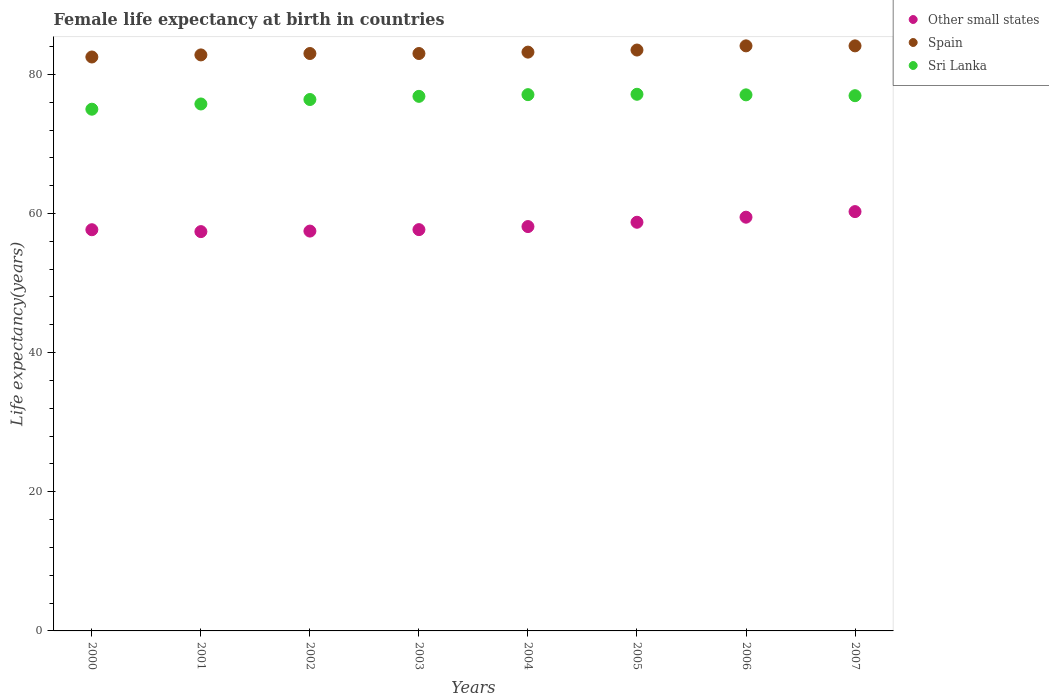How many different coloured dotlines are there?
Keep it short and to the point. 3. Is the number of dotlines equal to the number of legend labels?
Make the answer very short. Yes. What is the female life expectancy at birth in Other small states in 2005?
Offer a terse response. 58.74. Across all years, what is the maximum female life expectancy at birth in Other small states?
Provide a short and direct response. 60.28. Across all years, what is the minimum female life expectancy at birth in Spain?
Provide a succinct answer. 82.5. In which year was the female life expectancy at birth in Spain minimum?
Ensure brevity in your answer.  2000. What is the total female life expectancy at birth in Other small states in the graph?
Provide a succinct answer. 466.84. What is the difference between the female life expectancy at birth in Spain in 2000 and that in 2001?
Ensure brevity in your answer.  -0.3. What is the difference between the female life expectancy at birth in Sri Lanka in 2001 and the female life expectancy at birth in Other small states in 2007?
Your answer should be very brief. 15.47. What is the average female life expectancy at birth in Sri Lanka per year?
Provide a short and direct response. 76.52. In the year 2000, what is the difference between the female life expectancy at birth in Other small states and female life expectancy at birth in Sri Lanka?
Offer a very short reply. -17.32. In how many years, is the female life expectancy at birth in Other small states greater than 36 years?
Offer a terse response. 8. What is the ratio of the female life expectancy at birth in Other small states in 2003 to that in 2005?
Provide a short and direct response. 0.98. What is the difference between the highest and the second highest female life expectancy at birth in Other small states?
Offer a terse response. 0.8. What is the difference between the highest and the lowest female life expectancy at birth in Spain?
Ensure brevity in your answer.  1.6. Is the sum of the female life expectancy at birth in Other small states in 2001 and 2005 greater than the maximum female life expectancy at birth in Sri Lanka across all years?
Provide a succinct answer. Yes. How many dotlines are there?
Give a very brief answer. 3. Does the graph contain any zero values?
Offer a very short reply. No. Does the graph contain grids?
Keep it short and to the point. No. Where does the legend appear in the graph?
Make the answer very short. Top right. How are the legend labels stacked?
Keep it short and to the point. Vertical. What is the title of the graph?
Your answer should be compact. Female life expectancy at birth in countries. Does "Cameroon" appear as one of the legend labels in the graph?
Your response must be concise. No. What is the label or title of the Y-axis?
Make the answer very short. Life expectancy(years). What is the Life expectancy(years) of Other small states in 2000?
Give a very brief answer. 57.67. What is the Life expectancy(years) of Spain in 2000?
Offer a very short reply. 82.5. What is the Life expectancy(years) in Sri Lanka in 2000?
Provide a short and direct response. 75. What is the Life expectancy(years) of Other small states in 2001?
Provide a succinct answer. 57.4. What is the Life expectancy(years) in Spain in 2001?
Your response must be concise. 82.8. What is the Life expectancy(years) of Sri Lanka in 2001?
Provide a succinct answer. 75.75. What is the Life expectancy(years) of Other small states in 2002?
Your answer should be very brief. 57.47. What is the Life expectancy(years) in Spain in 2002?
Ensure brevity in your answer.  83. What is the Life expectancy(years) of Sri Lanka in 2002?
Give a very brief answer. 76.39. What is the Life expectancy(years) in Other small states in 2003?
Give a very brief answer. 57.68. What is the Life expectancy(years) of Spain in 2003?
Offer a very short reply. 83. What is the Life expectancy(years) of Sri Lanka in 2003?
Provide a succinct answer. 76.84. What is the Life expectancy(years) of Other small states in 2004?
Offer a terse response. 58.12. What is the Life expectancy(years) in Spain in 2004?
Keep it short and to the point. 83.2. What is the Life expectancy(years) of Sri Lanka in 2004?
Make the answer very short. 77.09. What is the Life expectancy(years) of Other small states in 2005?
Your answer should be compact. 58.74. What is the Life expectancy(years) of Spain in 2005?
Give a very brief answer. 83.5. What is the Life expectancy(years) in Sri Lanka in 2005?
Provide a short and direct response. 77.14. What is the Life expectancy(years) in Other small states in 2006?
Make the answer very short. 59.47. What is the Life expectancy(years) in Spain in 2006?
Offer a very short reply. 84.1. What is the Life expectancy(years) of Sri Lanka in 2006?
Give a very brief answer. 77.06. What is the Life expectancy(years) of Other small states in 2007?
Your answer should be compact. 60.28. What is the Life expectancy(years) in Spain in 2007?
Provide a short and direct response. 84.1. What is the Life expectancy(years) of Sri Lanka in 2007?
Your response must be concise. 76.94. Across all years, what is the maximum Life expectancy(years) of Other small states?
Your answer should be compact. 60.28. Across all years, what is the maximum Life expectancy(years) in Spain?
Your answer should be compact. 84.1. Across all years, what is the maximum Life expectancy(years) of Sri Lanka?
Offer a very short reply. 77.14. Across all years, what is the minimum Life expectancy(years) in Other small states?
Give a very brief answer. 57.4. Across all years, what is the minimum Life expectancy(years) of Spain?
Offer a very short reply. 82.5. Across all years, what is the minimum Life expectancy(years) in Sri Lanka?
Provide a short and direct response. 75. What is the total Life expectancy(years) in Other small states in the graph?
Ensure brevity in your answer.  466.84. What is the total Life expectancy(years) in Spain in the graph?
Give a very brief answer. 666.2. What is the total Life expectancy(years) of Sri Lanka in the graph?
Give a very brief answer. 612.19. What is the difference between the Life expectancy(years) in Other small states in 2000 and that in 2001?
Offer a very short reply. 0.27. What is the difference between the Life expectancy(years) in Spain in 2000 and that in 2001?
Offer a terse response. -0.3. What is the difference between the Life expectancy(years) in Sri Lanka in 2000 and that in 2001?
Provide a short and direct response. -0.75. What is the difference between the Life expectancy(years) of Other small states in 2000 and that in 2002?
Give a very brief answer. 0.2. What is the difference between the Life expectancy(years) in Sri Lanka in 2000 and that in 2002?
Your answer should be compact. -1.39. What is the difference between the Life expectancy(years) of Other small states in 2000 and that in 2003?
Give a very brief answer. -0.01. What is the difference between the Life expectancy(years) of Sri Lanka in 2000 and that in 2003?
Keep it short and to the point. -1.85. What is the difference between the Life expectancy(years) in Other small states in 2000 and that in 2004?
Your response must be concise. -0.45. What is the difference between the Life expectancy(years) in Sri Lanka in 2000 and that in 2004?
Your answer should be compact. -2.09. What is the difference between the Life expectancy(years) in Other small states in 2000 and that in 2005?
Keep it short and to the point. -1.07. What is the difference between the Life expectancy(years) of Sri Lanka in 2000 and that in 2005?
Offer a very short reply. -2.15. What is the difference between the Life expectancy(years) in Other small states in 2000 and that in 2006?
Offer a very short reply. -1.8. What is the difference between the Life expectancy(years) of Sri Lanka in 2000 and that in 2006?
Your answer should be compact. -2.06. What is the difference between the Life expectancy(years) of Other small states in 2000 and that in 2007?
Make the answer very short. -2.6. What is the difference between the Life expectancy(years) in Sri Lanka in 2000 and that in 2007?
Offer a very short reply. -1.94. What is the difference between the Life expectancy(years) of Other small states in 2001 and that in 2002?
Ensure brevity in your answer.  -0.08. What is the difference between the Life expectancy(years) in Spain in 2001 and that in 2002?
Your answer should be very brief. -0.2. What is the difference between the Life expectancy(years) of Sri Lanka in 2001 and that in 2002?
Provide a succinct answer. -0.64. What is the difference between the Life expectancy(years) in Other small states in 2001 and that in 2003?
Ensure brevity in your answer.  -0.29. What is the difference between the Life expectancy(years) of Spain in 2001 and that in 2003?
Your response must be concise. -0.2. What is the difference between the Life expectancy(years) in Sri Lanka in 2001 and that in 2003?
Your response must be concise. -1.1. What is the difference between the Life expectancy(years) of Other small states in 2001 and that in 2004?
Make the answer very short. -0.72. What is the difference between the Life expectancy(years) of Spain in 2001 and that in 2004?
Give a very brief answer. -0.4. What is the difference between the Life expectancy(years) of Sri Lanka in 2001 and that in 2004?
Your answer should be compact. -1.34. What is the difference between the Life expectancy(years) of Other small states in 2001 and that in 2005?
Ensure brevity in your answer.  -1.34. What is the difference between the Life expectancy(years) in Sri Lanka in 2001 and that in 2005?
Offer a very short reply. -1.39. What is the difference between the Life expectancy(years) in Other small states in 2001 and that in 2006?
Your answer should be very brief. -2.07. What is the difference between the Life expectancy(years) in Spain in 2001 and that in 2006?
Your answer should be very brief. -1.3. What is the difference between the Life expectancy(years) of Sri Lanka in 2001 and that in 2006?
Keep it short and to the point. -1.31. What is the difference between the Life expectancy(years) of Other small states in 2001 and that in 2007?
Provide a short and direct response. -2.88. What is the difference between the Life expectancy(years) of Sri Lanka in 2001 and that in 2007?
Your answer should be very brief. -1.19. What is the difference between the Life expectancy(years) of Other small states in 2002 and that in 2003?
Make the answer very short. -0.21. What is the difference between the Life expectancy(years) of Sri Lanka in 2002 and that in 2003?
Ensure brevity in your answer.  -0.46. What is the difference between the Life expectancy(years) in Other small states in 2002 and that in 2004?
Your answer should be very brief. -0.65. What is the difference between the Life expectancy(years) of Sri Lanka in 2002 and that in 2004?
Provide a short and direct response. -0.7. What is the difference between the Life expectancy(years) in Other small states in 2002 and that in 2005?
Provide a short and direct response. -1.27. What is the difference between the Life expectancy(years) in Spain in 2002 and that in 2005?
Your answer should be compact. -0.5. What is the difference between the Life expectancy(years) in Sri Lanka in 2002 and that in 2005?
Keep it short and to the point. -0.75. What is the difference between the Life expectancy(years) in Other small states in 2002 and that in 2006?
Give a very brief answer. -2. What is the difference between the Life expectancy(years) in Sri Lanka in 2002 and that in 2006?
Provide a succinct answer. -0.67. What is the difference between the Life expectancy(years) in Other small states in 2002 and that in 2007?
Make the answer very short. -2.8. What is the difference between the Life expectancy(years) in Sri Lanka in 2002 and that in 2007?
Your response must be concise. -0.55. What is the difference between the Life expectancy(years) of Other small states in 2003 and that in 2004?
Provide a short and direct response. -0.44. What is the difference between the Life expectancy(years) in Spain in 2003 and that in 2004?
Give a very brief answer. -0.2. What is the difference between the Life expectancy(years) of Sri Lanka in 2003 and that in 2004?
Provide a short and direct response. -0.24. What is the difference between the Life expectancy(years) in Other small states in 2003 and that in 2005?
Give a very brief answer. -1.06. What is the difference between the Life expectancy(years) in Spain in 2003 and that in 2005?
Make the answer very short. -0.5. What is the difference between the Life expectancy(years) of Sri Lanka in 2003 and that in 2005?
Provide a short and direct response. -0.3. What is the difference between the Life expectancy(years) of Other small states in 2003 and that in 2006?
Your response must be concise. -1.79. What is the difference between the Life expectancy(years) in Sri Lanka in 2003 and that in 2006?
Give a very brief answer. -0.21. What is the difference between the Life expectancy(years) of Other small states in 2003 and that in 2007?
Your answer should be compact. -2.59. What is the difference between the Life expectancy(years) in Sri Lanka in 2003 and that in 2007?
Provide a short and direct response. -0.09. What is the difference between the Life expectancy(years) in Other small states in 2004 and that in 2005?
Ensure brevity in your answer.  -0.62. What is the difference between the Life expectancy(years) in Sri Lanka in 2004 and that in 2005?
Make the answer very short. -0.05. What is the difference between the Life expectancy(years) in Other small states in 2004 and that in 2006?
Provide a succinct answer. -1.35. What is the difference between the Life expectancy(years) of Spain in 2004 and that in 2006?
Provide a short and direct response. -0.9. What is the difference between the Life expectancy(years) of Sri Lanka in 2004 and that in 2006?
Your answer should be very brief. 0.03. What is the difference between the Life expectancy(years) of Other small states in 2004 and that in 2007?
Make the answer very short. -2.15. What is the difference between the Life expectancy(years) in Sri Lanka in 2004 and that in 2007?
Offer a very short reply. 0.15. What is the difference between the Life expectancy(years) in Other small states in 2005 and that in 2006?
Offer a terse response. -0.73. What is the difference between the Life expectancy(years) in Sri Lanka in 2005 and that in 2006?
Ensure brevity in your answer.  0.08. What is the difference between the Life expectancy(years) of Other small states in 2005 and that in 2007?
Ensure brevity in your answer.  -1.53. What is the difference between the Life expectancy(years) of Sri Lanka in 2005 and that in 2007?
Your answer should be compact. 0.2. What is the difference between the Life expectancy(years) of Other small states in 2006 and that in 2007?
Ensure brevity in your answer.  -0.8. What is the difference between the Life expectancy(years) of Sri Lanka in 2006 and that in 2007?
Keep it short and to the point. 0.12. What is the difference between the Life expectancy(years) in Other small states in 2000 and the Life expectancy(years) in Spain in 2001?
Offer a terse response. -25.13. What is the difference between the Life expectancy(years) in Other small states in 2000 and the Life expectancy(years) in Sri Lanka in 2001?
Your answer should be very brief. -18.07. What is the difference between the Life expectancy(years) of Spain in 2000 and the Life expectancy(years) of Sri Lanka in 2001?
Provide a succinct answer. 6.75. What is the difference between the Life expectancy(years) of Other small states in 2000 and the Life expectancy(years) of Spain in 2002?
Provide a succinct answer. -25.33. What is the difference between the Life expectancy(years) of Other small states in 2000 and the Life expectancy(years) of Sri Lanka in 2002?
Ensure brevity in your answer.  -18.72. What is the difference between the Life expectancy(years) of Spain in 2000 and the Life expectancy(years) of Sri Lanka in 2002?
Keep it short and to the point. 6.11. What is the difference between the Life expectancy(years) in Other small states in 2000 and the Life expectancy(years) in Spain in 2003?
Give a very brief answer. -25.33. What is the difference between the Life expectancy(years) of Other small states in 2000 and the Life expectancy(years) of Sri Lanka in 2003?
Your answer should be compact. -19.17. What is the difference between the Life expectancy(years) of Spain in 2000 and the Life expectancy(years) of Sri Lanka in 2003?
Offer a very short reply. 5.66. What is the difference between the Life expectancy(years) in Other small states in 2000 and the Life expectancy(years) in Spain in 2004?
Ensure brevity in your answer.  -25.53. What is the difference between the Life expectancy(years) in Other small states in 2000 and the Life expectancy(years) in Sri Lanka in 2004?
Your response must be concise. -19.42. What is the difference between the Life expectancy(years) of Spain in 2000 and the Life expectancy(years) of Sri Lanka in 2004?
Offer a very short reply. 5.41. What is the difference between the Life expectancy(years) of Other small states in 2000 and the Life expectancy(years) of Spain in 2005?
Keep it short and to the point. -25.83. What is the difference between the Life expectancy(years) of Other small states in 2000 and the Life expectancy(years) of Sri Lanka in 2005?
Ensure brevity in your answer.  -19.47. What is the difference between the Life expectancy(years) in Spain in 2000 and the Life expectancy(years) in Sri Lanka in 2005?
Your response must be concise. 5.36. What is the difference between the Life expectancy(years) in Other small states in 2000 and the Life expectancy(years) in Spain in 2006?
Ensure brevity in your answer.  -26.43. What is the difference between the Life expectancy(years) of Other small states in 2000 and the Life expectancy(years) of Sri Lanka in 2006?
Offer a very short reply. -19.39. What is the difference between the Life expectancy(years) in Spain in 2000 and the Life expectancy(years) in Sri Lanka in 2006?
Your answer should be compact. 5.44. What is the difference between the Life expectancy(years) of Other small states in 2000 and the Life expectancy(years) of Spain in 2007?
Your response must be concise. -26.43. What is the difference between the Life expectancy(years) of Other small states in 2000 and the Life expectancy(years) of Sri Lanka in 2007?
Provide a succinct answer. -19.27. What is the difference between the Life expectancy(years) in Spain in 2000 and the Life expectancy(years) in Sri Lanka in 2007?
Your answer should be compact. 5.56. What is the difference between the Life expectancy(years) of Other small states in 2001 and the Life expectancy(years) of Spain in 2002?
Ensure brevity in your answer.  -25.6. What is the difference between the Life expectancy(years) of Other small states in 2001 and the Life expectancy(years) of Sri Lanka in 2002?
Your response must be concise. -18.99. What is the difference between the Life expectancy(years) in Spain in 2001 and the Life expectancy(years) in Sri Lanka in 2002?
Your answer should be compact. 6.41. What is the difference between the Life expectancy(years) in Other small states in 2001 and the Life expectancy(years) in Spain in 2003?
Your answer should be very brief. -25.6. What is the difference between the Life expectancy(years) of Other small states in 2001 and the Life expectancy(years) of Sri Lanka in 2003?
Ensure brevity in your answer.  -19.44. What is the difference between the Life expectancy(years) in Spain in 2001 and the Life expectancy(years) in Sri Lanka in 2003?
Your response must be concise. 5.96. What is the difference between the Life expectancy(years) of Other small states in 2001 and the Life expectancy(years) of Spain in 2004?
Offer a very short reply. -25.8. What is the difference between the Life expectancy(years) of Other small states in 2001 and the Life expectancy(years) of Sri Lanka in 2004?
Keep it short and to the point. -19.69. What is the difference between the Life expectancy(years) in Spain in 2001 and the Life expectancy(years) in Sri Lanka in 2004?
Provide a short and direct response. 5.71. What is the difference between the Life expectancy(years) of Other small states in 2001 and the Life expectancy(years) of Spain in 2005?
Ensure brevity in your answer.  -26.1. What is the difference between the Life expectancy(years) of Other small states in 2001 and the Life expectancy(years) of Sri Lanka in 2005?
Ensure brevity in your answer.  -19.74. What is the difference between the Life expectancy(years) in Spain in 2001 and the Life expectancy(years) in Sri Lanka in 2005?
Make the answer very short. 5.66. What is the difference between the Life expectancy(years) in Other small states in 2001 and the Life expectancy(years) in Spain in 2006?
Your response must be concise. -26.7. What is the difference between the Life expectancy(years) in Other small states in 2001 and the Life expectancy(years) in Sri Lanka in 2006?
Keep it short and to the point. -19.66. What is the difference between the Life expectancy(years) in Spain in 2001 and the Life expectancy(years) in Sri Lanka in 2006?
Provide a short and direct response. 5.74. What is the difference between the Life expectancy(years) in Other small states in 2001 and the Life expectancy(years) in Spain in 2007?
Your response must be concise. -26.7. What is the difference between the Life expectancy(years) in Other small states in 2001 and the Life expectancy(years) in Sri Lanka in 2007?
Provide a succinct answer. -19.54. What is the difference between the Life expectancy(years) in Spain in 2001 and the Life expectancy(years) in Sri Lanka in 2007?
Provide a short and direct response. 5.86. What is the difference between the Life expectancy(years) in Other small states in 2002 and the Life expectancy(years) in Spain in 2003?
Your response must be concise. -25.53. What is the difference between the Life expectancy(years) of Other small states in 2002 and the Life expectancy(years) of Sri Lanka in 2003?
Make the answer very short. -19.37. What is the difference between the Life expectancy(years) in Spain in 2002 and the Life expectancy(years) in Sri Lanka in 2003?
Ensure brevity in your answer.  6.16. What is the difference between the Life expectancy(years) of Other small states in 2002 and the Life expectancy(years) of Spain in 2004?
Keep it short and to the point. -25.73. What is the difference between the Life expectancy(years) in Other small states in 2002 and the Life expectancy(years) in Sri Lanka in 2004?
Keep it short and to the point. -19.61. What is the difference between the Life expectancy(years) in Spain in 2002 and the Life expectancy(years) in Sri Lanka in 2004?
Keep it short and to the point. 5.91. What is the difference between the Life expectancy(years) in Other small states in 2002 and the Life expectancy(years) in Spain in 2005?
Provide a succinct answer. -26.03. What is the difference between the Life expectancy(years) of Other small states in 2002 and the Life expectancy(years) of Sri Lanka in 2005?
Your answer should be compact. -19.67. What is the difference between the Life expectancy(years) in Spain in 2002 and the Life expectancy(years) in Sri Lanka in 2005?
Offer a very short reply. 5.86. What is the difference between the Life expectancy(years) in Other small states in 2002 and the Life expectancy(years) in Spain in 2006?
Your answer should be compact. -26.63. What is the difference between the Life expectancy(years) in Other small states in 2002 and the Life expectancy(years) in Sri Lanka in 2006?
Offer a very short reply. -19.58. What is the difference between the Life expectancy(years) of Spain in 2002 and the Life expectancy(years) of Sri Lanka in 2006?
Give a very brief answer. 5.94. What is the difference between the Life expectancy(years) of Other small states in 2002 and the Life expectancy(years) of Spain in 2007?
Offer a very short reply. -26.63. What is the difference between the Life expectancy(years) in Other small states in 2002 and the Life expectancy(years) in Sri Lanka in 2007?
Offer a very short reply. -19.46. What is the difference between the Life expectancy(years) of Spain in 2002 and the Life expectancy(years) of Sri Lanka in 2007?
Make the answer very short. 6.06. What is the difference between the Life expectancy(years) in Other small states in 2003 and the Life expectancy(years) in Spain in 2004?
Provide a short and direct response. -25.52. What is the difference between the Life expectancy(years) of Other small states in 2003 and the Life expectancy(years) of Sri Lanka in 2004?
Offer a terse response. -19.4. What is the difference between the Life expectancy(years) in Spain in 2003 and the Life expectancy(years) in Sri Lanka in 2004?
Provide a succinct answer. 5.91. What is the difference between the Life expectancy(years) of Other small states in 2003 and the Life expectancy(years) of Spain in 2005?
Give a very brief answer. -25.82. What is the difference between the Life expectancy(years) in Other small states in 2003 and the Life expectancy(years) in Sri Lanka in 2005?
Provide a succinct answer. -19.46. What is the difference between the Life expectancy(years) in Spain in 2003 and the Life expectancy(years) in Sri Lanka in 2005?
Offer a very short reply. 5.86. What is the difference between the Life expectancy(years) in Other small states in 2003 and the Life expectancy(years) in Spain in 2006?
Provide a succinct answer. -26.42. What is the difference between the Life expectancy(years) of Other small states in 2003 and the Life expectancy(years) of Sri Lanka in 2006?
Your answer should be compact. -19.37. What is the difference between the Life expectancy(years) in Spain in 2003 and the Life expectancy(years) in Sri Lanka in 2006?
Your answer should be very brief. 5.94. What is the difference between the Life expectancy(years) of Other small states in 2003 and the Life expectancy(years) of Spain in 2007?
Provide a succinct answer. -26.42. What is the difference between the Life expectancy(years) in Other small states in 2003 and the Life expectancy(years) in Sri Lanka in 2007?
Offer a very short reply. -19.25. What is the difference between the Life expectancy(years) in Spain in 2003 and the Life expectancy(years) in Sri Lanka in 2007?
Your answer should be very brief. 6.06. What is the difference between the Life expectancy(years) of Other small states in 2004 and the Life expectancy(years) of Spain in 2005?
Offer a terse response. -25.38. What is the difference between the Life expectancy(years) in Other small states in 2004 and the Life expectancy(years) in Sri Lanka in 2005?
Your answer should be very brief. -19.02. What is the difference between the Life expectancy(years) of Spain in 2004 and the Life expectancy(years) of Sri Lanka in 2005?
Provide a short and direct response. 6.06. What is the difference between the Life expectancy(years) in Other small states in 2004 and the Life expectancy(years) in Spain in 2006?
Give a very brief answer. -25.98. What is the difference between the Life expectancy(years) in Other small states in 2004 and the Life expectancy(years) in Sri Lanka in 2006?
Your answer should be very brief. -18.93. What is the difference between the Life expectancy(years) in Spain in 2004 and the Life expectancy(years) in Sri Lanka in 2006?
Offer a terse response. 6.14. What is the difference between the Life expectancy(years) in Other small states in 2004 and the Life expectancy(years) in Spain in 2007?
Make the answer very short. -25.98. What is the difference between the Life expectancy(years) in Other small states in 2004 and the Life expectancy(years) in Sri Lanka in 2007?
Provide a short and direct response. -18.81. What is the difference between the Life expectancy(years) of Spain in 2004 and the Life expectancy(years) of Sri Lanka in 2007?
Your answer should be compact. 6.26. What is the difference between the Life expectancy(years) in Other small states in 2005 and the Life expectancy(years) in Spain in 2006?
Your answer should be compact. -25.36. What is the difference between the Life expectancy(years) in Other small states in 2005 and the Life expectancy(years) in Sri Lanka in 2006?
Your answer should be compact. -18.31. What is the difference between the Life expectancy(years) in Spain in 2005 and the Life expectancy(years) in Sri Lanka in 2006?
Offer a very short reply. 6.44. What is the difference between the Life expectancy(years) of Other small states in 2005 and the Life expectancy(years) of Spain in 2007?
Keep it short and to the point. -25.36. What is the difference between the Life expectancy(years) in Other small states in 2005 and the Life expectancy(years) in Sri Lanka in 2007?
Offer a very short reply. -18.19. What is the difference between the Life expectancy(years) in Spain in 2005 and the Life expectancy(years) in Sri Lanka in 2007?
Provide a short and direct response. 6.56. What is the difference between the Life expectancy(years) in Other small states in 2006 and the Life expectancy(years) in Spain in 2007?
Your answer should be very brief. -24.63. What is the difference between the Life expectancy(years) of Other small states in 2006 and the Life expectancy(years) of Sri Lanka in 2007?
Offer a terse response. -17.46. What is the difference between the Life expectancy(years) in Spain in 2006 and the Life expectancy(years) in Sri Lanka in 2007?
Provide a short and direct response. 7.16. What is the average Life expectancy(years) of Other small states per year?
Your answer should be very brief. 58.36. What is the average Life expectancy(years) of Spain per year?
Your answer should be compact. 83.28. What is the average Life expectancy(years) in Sri Lanka per year?
Your answer should be very brief. 76.52. In the year 2000, what is the difference between the Life expectancy(years) in Other small states and Life expectancy(years) in Spain?
Your answer should be very brief. -24.83. In the year 2000, what is the difference between the Life expectancy(years) of Other small states and Life expectancy(years) of Sri Lanka?
Provide a short and direct response. -17.32. In the year 2000, what is the difference between the Life expectancy(years) in Spain and Life expectancy(years) in Sri Lanka?
Your answer should be compact. 7.5. In the year 2001, what is the difference between the Life expectancy(years) in Other small states and Life expectancy(years) in Spain?
Offer a very short reply. -25.4. In the year 2001, what is the difference between the Life expectancy(years) in Other small states and Life expectancy(years) in Sri Lanka?
Your answer should be compact. -18.35. In the year 2001, what is the difference between the Life expectancy(years) of Spain and Life expectancy(years) of Sri Lanka?
Offer a very short reply. 7.05. In the year 2002, what is the difference between the Life expectancy(years) of Other small states and Life expectancy(years) of Spain?
Your answer should be very brief. -25.53. In the year 2002, what is the difference between the Life expectancy(years) in Other small states and Life expectancy(years) in Sri Lanka?
Your response must be concise. -18.91. In the year 2002, what is the difference between the Life expectancy(years) of Spain and Life expectancy(years) of Sri Lanka?
Your response must be concise. 6.61. In the year 2003, what is the difference between the Life expectancy(years) in Other small states and Life expectancy(years) in Spain?
Provide a succinct answer. -25.32. In the year 2003, what is the difference between the Life expectancy(years) in Other small states and Life expectancy(years) in Sri Lanka?
Keep it short and to the point. -19.16. In the year 2003, what is the difference between the Life expectancy(years) in Spain and Life expectancy(years) in Sri Lanka?
Provide a succinct answer. 6.16. In the year 2004, what is the difference between the Life expectancy(years) in Other small states and Life expectancy(years) in Spain?
Offer a very short reply. -25.08. In the year 2004, what is the difference between the Life expectancy(years) in Other small states and Life expectancy(years) in Sri Lanka?
Provide a short and direct response. -18.96. In the year 2004, what is the difference between the Life expectancy(years) of Spain and Life expectancy(years) of Sri Lanka?
Your answer should be very brief. 6.11. In the year 2005, what is the difference between the Life expectancy(years) in Other small states and Life expectancy(years) in Spain?
Provide a short and direct response. -24.76. In the year 2005, what is the difference between the Life expectancy(years) in Other small states and Life expectancy(years) in Sri Lanka?
Your answer should be very brief. -18.4. In the year 2005, what is the difference between the Life expectancy(years) of Spain and Life expectancy(years) of Sri Lanka?
Your answer should be compact. 6.36. In the year 2006, what is the difference between the Life expectancy(years) of Other small states and Life expectancy(years) of Spain?
Ensure brevity in your answer.  -24.63. In the year 2006, what is the difference between the Life expectancy(years) of Other small states and Life expectancy(years) of Sri Lanka?
Provide a succinct answer. -17.59. In the year 2006, what is the difference between the Life expectancy(years) in Spain and Life expectancy(years) in Sri Lanka?
Provide a succinct answer. 7.04. In the year 2007, what is the difference between the Life expectancy(years) in Other small states and Life expectancy(years) in Spain?
Provide a succinct answer. -23.82. In the year 2007, what is the difference between the Life expectancy(years) in Other small states and Life expectancy(years) in Sri Lanka?
Make the answer very short. -16.66. In the year 2007, what is the difference between the Life expectancy(years) in Spain and Life expectancy(years) in Sri Lanka?
Your answer should be very brief. 7.16. What is the ratio of the Life expectancy(years) of Other small states in 2000 to that in 2001?
Your answer should be very brief. 1. What is the ratio of the Life expectancy(years) of Spain in 2000 to that in 2002?
Provide a succinct answer. 0.99. What is the ratio of the Life expectancy(years) in Sri Lanka in 2000 to that in 2002?
Your answer should be very brief. 0.98. What is the ratio of the Life expectancy(years) in Other small states in 2000 to that in 2003?
Your answer should be compact. 1. What is the ratio of the Life expectancy(years) in Spain in 2000 to that in 2003?
Your answer should be compact. 0.99. What is the ratio of the Life expectancy(years) of Spain in 2000 to that in 2004?
Your answer should be compact. 0.99. What is the ratio of the Life expectancy(years) in Sri Lanka in 2000 to that in 2004?
Provide a succinct answer. 0.97. What is the ratio of the Life expectancy(years) of Other small states in 2000 to that in 2005?
Offer a terse response. 0.98. What is the ratio of the Life expectancy(years) in Spain in 2000 to that in 2005?
Ensure brevity in your answer.  0.99. What is the ratio of the Life expectancy(years) in Sri Lanka in 2000 to that in 2005?
Offer a very short reply. 0.97. What is the ratio of the Life expectancy(years) of Other small states in 2000 to that in 2006?
Keep it short and to the point. 0.97. What is the ratio of the Life expectancy(years) in Sri Lanka in 2000 to that in 2006?
Provide a short and direct response. 0.97. What is the ratio of the Life expectancy(years) of Other small states in 2000 to that in 2007?
Provide a succinct answer. 0.96. What is the ratio of the Life expectancy(years) of Spain in 2000 to that in 2007?
Your answer should be very brief. 0.98. What is the ratio of the Life expectancy(years) of Sri Lanka in 2000 to that in 2007?
Offer a terse response. 0.97. What is the ratio of the Life expectancy(years) in Other small states in 2001 to that in 2002?
Ensure brevity in your answer.  1. What is the ratio of the Life expectancy(years) of Other small states in 2001 to that in 2003?
Your answer should be compact. 0.99. What is the ratio of the Life expectancy(years) in Spain in 2001 to that in 2003?
Keep it short and to the point. 1. What is the ratio of the Life expectancy(years) of Sri Lanka in 2001 to that in 2003?
Your answer should be very brief. 0.99. What is the ratio of the Life expectancy(years) of Other small states in 2001 to that in 2004?
Give a very brief answer. 0.99. What is the ratio of the Life expectancy(years) in Spain in 2001 to that in 2004?
Make the answer very short. 1. What is the ratio of the Life expectancy(years) of Sri Lanka in 2001 to that in 2004?
Give a very brief answer. 0.98. What is the ratio of the Life expectancy(years) of Other small states in 2001 to that in 2005?
Provide a succinct answer. 0.98. What is the ratio of the Life expectancy(years) of Spain in 2001 to that in 2005?
Provide a short and direct response. 0.99. What is the ratio of the Life expectancy(years) of Sri Lanka in 2001 to that in 2005?
Your answer should be compact. 0.98. What is the ratio of the Life expectancy(years) of Other small states in 2001 to that in 2006?
Give a very brief answer. 0.97. What is the ratio of the Life expectancy(years) in Spain in 2001 to that in 2006?
Keep it short and to the point. 0.98. What is the ratio of the Life expectancy(years) of Sri Lanka in 2001 to that in 2006?
Give a very brief answer. 0.98. What is the ratio of the Life expectancy(years) of Other small states in 2001 to that in 2007?
Give a very brief answer. 0.95. What is the ratio of the Life expectancy(years) in Spain in 2001 to that in 2007?
Offer a terse response. 0.98. What is the ratio of the Life expectancy(years) in Sri Lanka in 2001 to that in 2007?
Make the answer very short. 0.98. What is the ratio of the Life expectancy(years) in Other small states in 2002 to that in 2003?
Offer a very short reply. 1. What is the ratio of the Life expectancy(years) in Spain in 2002 to that in 2004?
Keep it short and to the point. 1. What is the ratio of the Life expectancy(years) of Sri Lanka in 2002 to that in 2004?
Give a very brief answer. 0.99. What is the ratio of the Life expectancy(years) of Other small states in 2002 to that in 2005?
Ensure brevity in your answer.  0.98. What is the ratio of the Life expectancy(years) in Sri Lanka in 2002 to that in 2005?
Your response must be concise. 0.99. What is the ratio of the Life expectancy(years) of Other small states in 2002 to that in 2006?
Offer a very short reply. 0.97. What is the ratio of the Life expectancy(years) in Spain in 2002 to that in 2006?
Offer a terse response. 0.99. What is the ratio of the Life expectancy(years) in Sri Lanka in 2002 to that in 2006?
Keep it short and to the point. 0.99. What is the ratio of the Life expectancy(years) of Other small states in 2002 to that in 2007?
Provide a short and direct response. 0.95. What is the ratio of the Life expectancy(years) in Spain in 2002 to that in 2007?
Provide a succinct answer. 0.99. What is the ratio of the Life expectancy(years) of Other small states in 2003 to that in 2004?
Provide a short and direct response. 0.99. What is the ratio of the Life expectancy(years) in Sri Lanka in 2003 to that in 2004?
Keep it short and to the point. 1. What is the ratio of the Life expectancy(years) of Spain in 2003 to that in 2005?
Your answer should be very brief. 0.99. What is the ratio of the Life expectancy(years) of Other small states in 2003 to that in 2006?
Offer a very short reply. 0.97. What is the ratio of the Life expectancy(years) of Spain in 2003 to that in 2006?
Make the answer very short. 0.99. What is the ratio of the Life expectancy(years) of Spain in 2003 to that in 2007?
Offer a very short reply. 0.99. What is the ratio of the Life expectancy(years) in Other small states in 2004 to that in 2005?
Provide a short and direct response. 0.99. What is the ratio of the Life expectancy(years) in Spain in 2004 to that in 2005?
Provide a succinct answer. 1. What is the ratio of the Life expectancy(years) of Other small states in 2004 to that in 2006?
Make the answer very short. 0.98. What is the ratio of the Life expectancy(years) of Spain in 2004 to that in 2006?
Provide a succinct answer. 0.99. What is the ratio of the Life expectancy(years) of Other small states in 2004 to that in 2007?
Ensure brevity in your answer.  0.96. What is the ratio of the Life expectancy(years) in Spain in 2004 to that in 2007?
Make the answer very short. 0.99. What is the ratio of the Life expectancy(years) in Sri Lanka in 2004 to that in 2007?
Offer a terse response. 1. What is the ratio of the Life expectancy(years) of Other small states in 2005 to that in 2006?
Your answer should be very brief. 0.99. What is the ratio of the Life expectancy(years) of Sri Lanka in 2005 to that in 2006?
Your response must be concise. 1. What is the ratio of the Life expectancy(years) in Other small states in 2005 to that in 2007?
Give a very brief answer. 0.97. What is the ratio of the Life expectancy(years) in Sri Lanka in 2005 to that in 2007?
Offer a terse response. 1. What is the ratio of the Life expectancy(years) of Other small states in 2006 to that in 2007?
Ensure brevity in your answer.  0.99. What is the ratio of the Life expectancy(years) in Spain in 2006 to that in 2007?
Your answer should be very brief. 1. What is the difference between the highest and the second highest Life expectancy(years) of Other small states?
Provide a short and direct response. 0.8. What is the difference between the highest and the second highest Life expectancy(years) of Spain?
Provide a succinct answer. 0. What is the difference between the highest and the second highest Life expectancy(years) of Sri Lanka?
Offer a terse response. 0.05. What is the difference between the highest and the lowest Life expectancy(years) in Other small states?
Your response must be concise. 2.88. What is the difference between the highest and the lowest Life expectancy(years) of Spain?
Give a very brief answer. 1.6. What is the difference between the highest and the lowest Life expectancy(years) of Sri Lanka?
Your answer should be very brief. 2.15. 